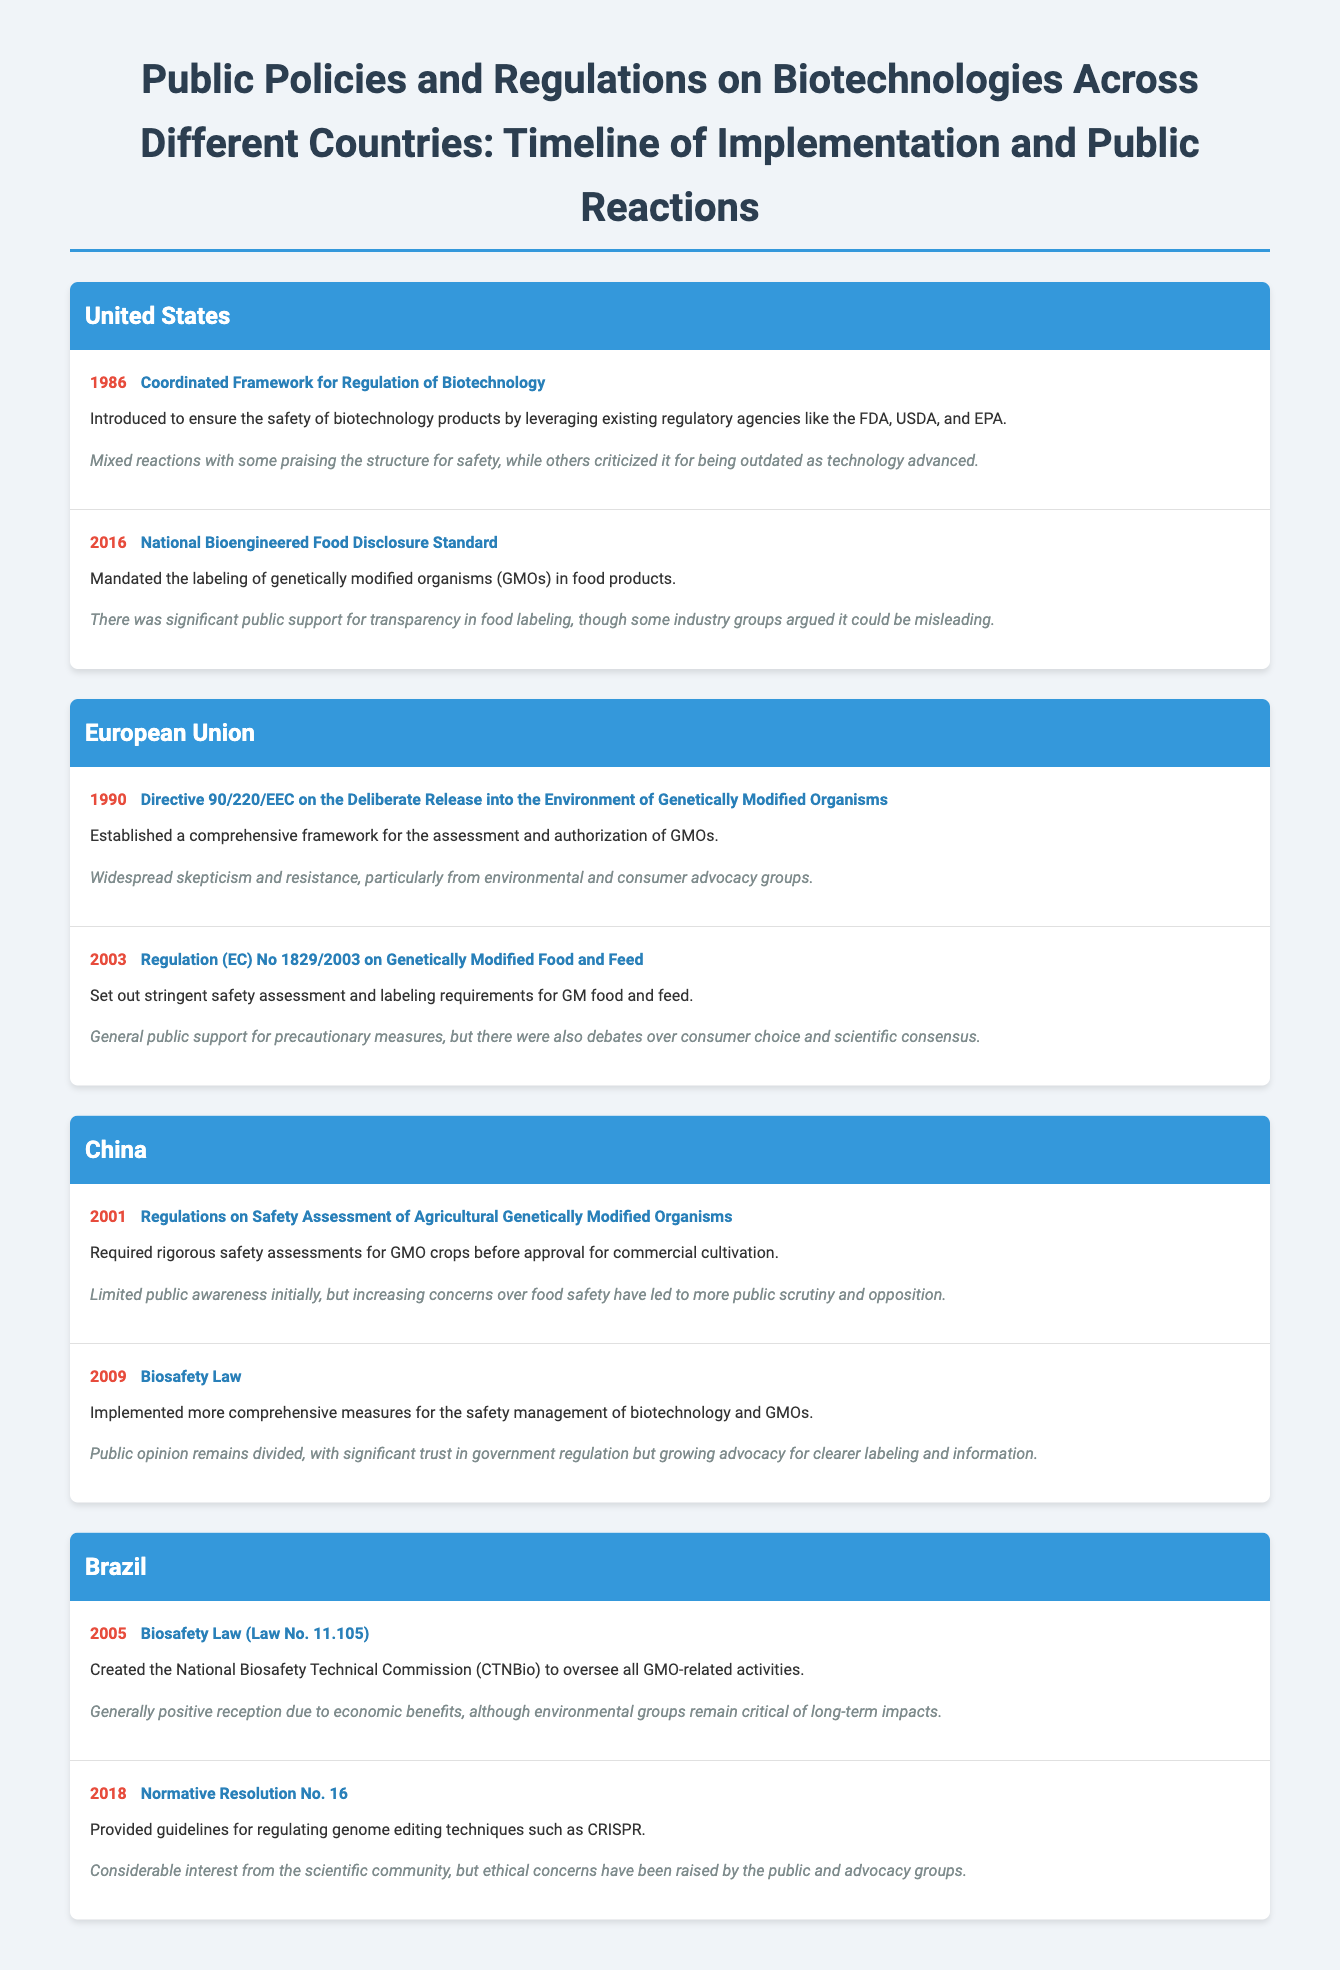what year was the Coordinated Framework for Regulation of Biotechnology introduced? The document provides a timeline of policies, indicating that the Coordinated Framework was introduced in 1986.
Answer: 1986 what is the policy name for the EU directive established in 1990? The document mentions the policy called Directive 90/220/EEC regarding the deliberate release of GMOs, which was established in 1990.
Answer: Directive 90/220/EEC on the Deliberate Release into the Environment of Genetically Modified Organisms what did the National Bioengineered Food Disclosure Standard mandate? The details indicate that this standard mandated the labeling of GMOs in food products.
Answer: Labeling of genetically modified organisms (GMOs) which country implemented the Biosafety Law in 2009? The document lists China as the country that implemented the Biosafety Law in 2009.
Answer: China how did the public react to the Biosafety Law in China? The document states that public opinion remains divided regarding the Biosafety Law, highlighting trust in government regulation yet concerns for clearer labeling.
Answer: Divided what year did Brazil pass the Biosafety Law? According to the timeline in the document, Brazil passed the Biosafety Law in 2005.
Answer: 2005 which country’s policy included guidelines for genome editing techniques like CRISPR? The document indicates that Brazil's Normative Resolution No. 16 provided these guidelines.
Answer: Brazil what was a major public reaction to the European Union’s Regulation No. 1829/2003? The document notes that there was general public support for precautionary measures, reflecting a positive public reaction.
Answer: General public support 